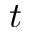Convert formula to latex. <formula><loc_0><loc_0><loc_500><loc_500>t</formula> 